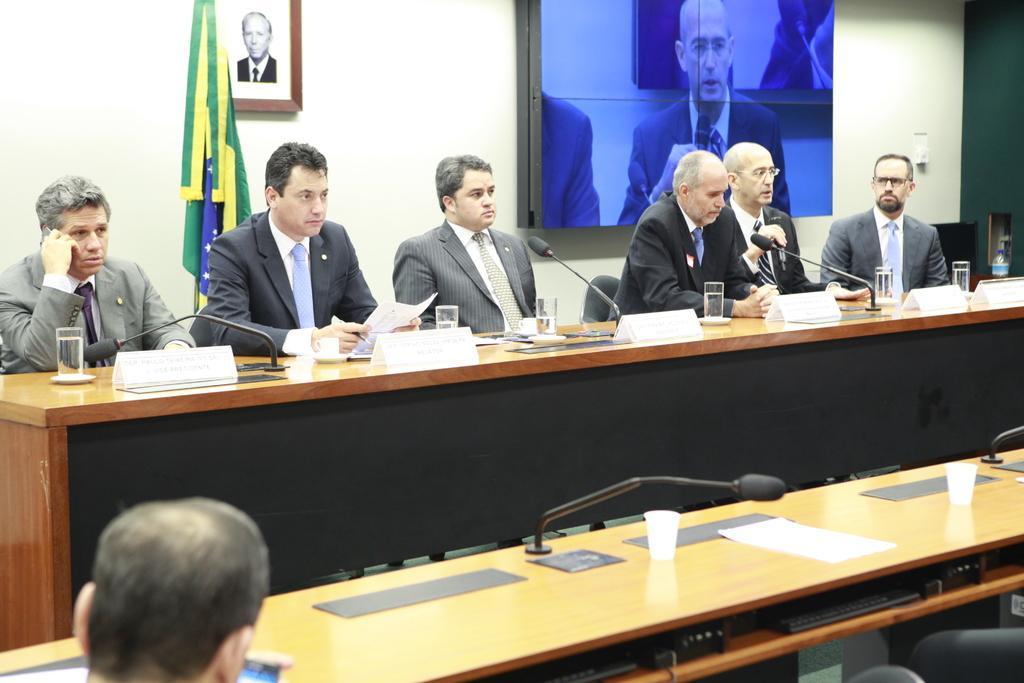Can you describe this image briefly? This image consists of many people wearing suits. It looks like a conference hall. In the front, there is a table on which there are mice and glasses along with name plates. In the background, there is a wall on which a frame and screen are fixed. And there is a flag. 